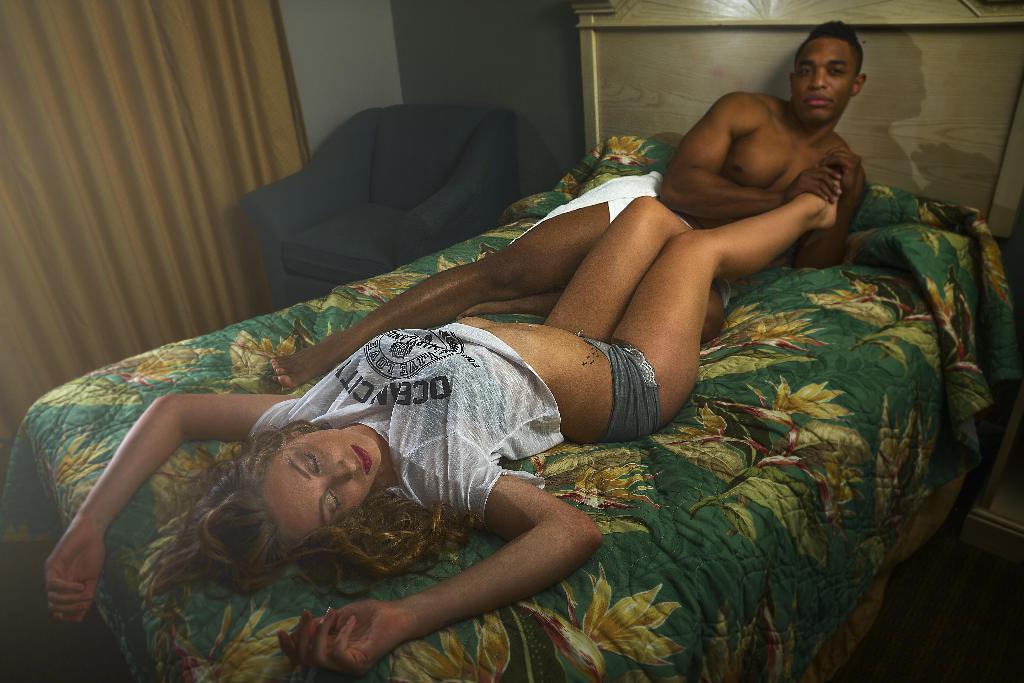Can you describe this image briefly? In the center of the image we can see two persons are lying on a bed. In the background of the image we can see a couch, curtain, wall. In the bottom right corner we can see the floor. 